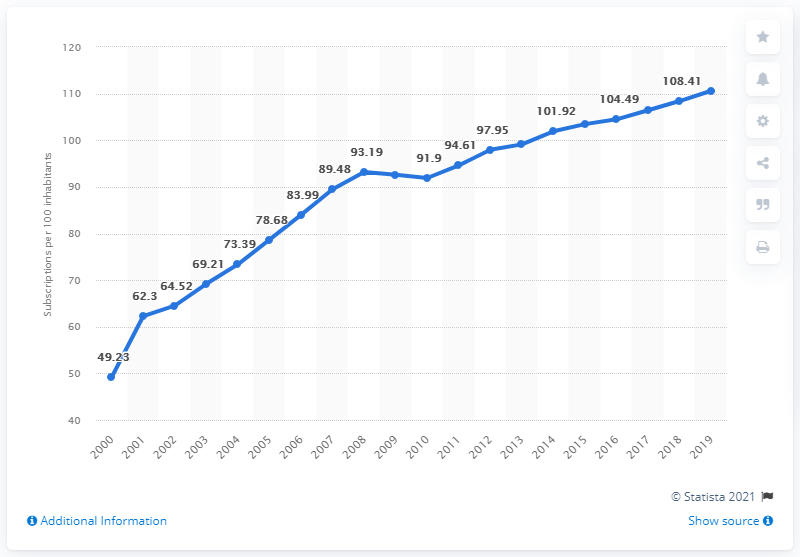List a handful of essential elements in this visual. The graph is increasing. In the year 2000, the average number of mobile cellular subscriptions per 100 inhabitants in France was registered. The highest value is greater than the 2008 by 15.22. 